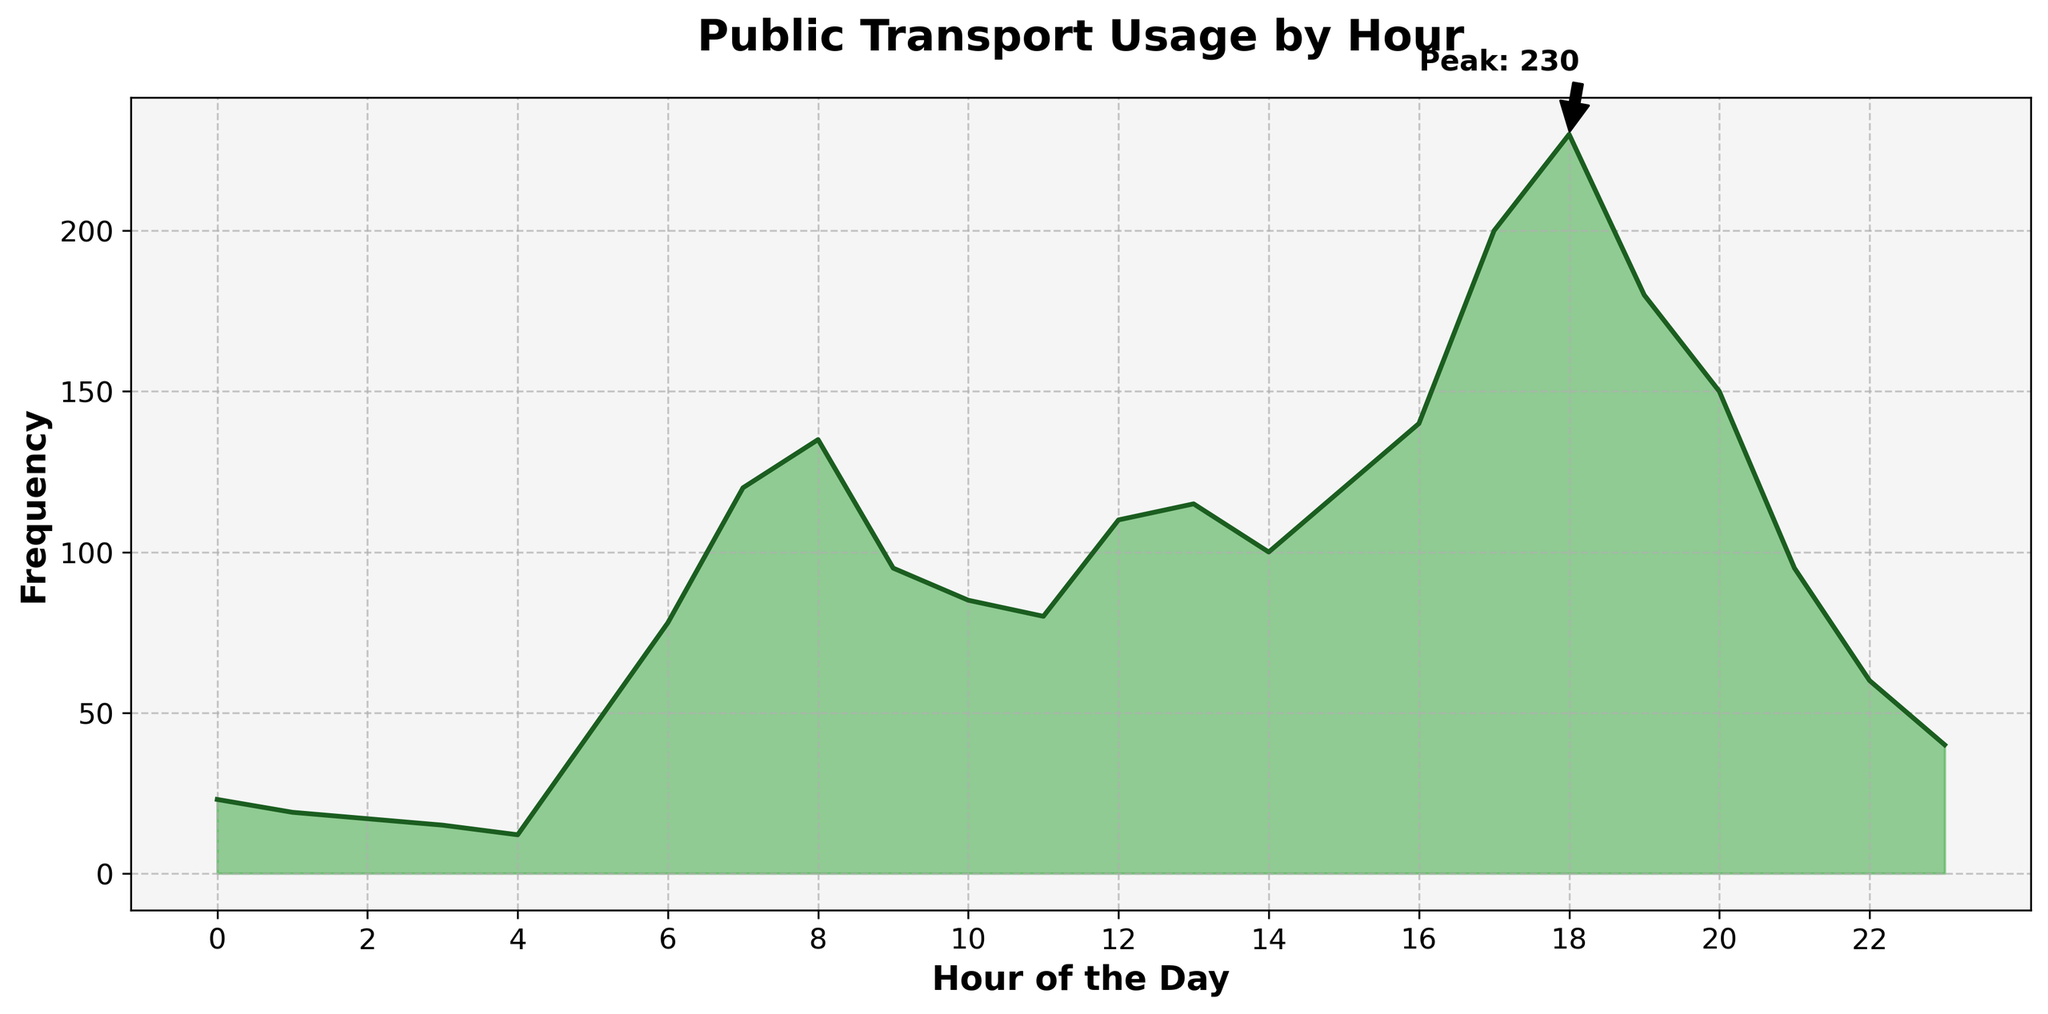What is the title of the figure? The title is usually located at the top of the figure and clearly states what the figure is about. In this case, it is "Public Transport Usage by Hour".
Answer: Public Transport Usage by Hour Which hour has the peak frequency of public transport usage? The peak hour can be seen where the frequency is annotated with "Peak: 230" on the figure.
Answer: 17 What color is used to fill the area under the density plot? The fill color under the density plot is a specific shade of green that can be visually identified.
Answer: Green How many major tick marks are on the x-axis? The x-axis corresponds to the hours of the day, and major tick marks are at 2-hour intervals. You can count these intervals starting from 0 to 22.
Answer: 12 What is the frequency at 8 AM? Locate 8 on the x-axis and trace vertically to where it intersects the plotted line, which shows the frequency value. This is given as 135 in the original data.
Answer: 135 What is the difference in frequency between 6 AM and 10 AM? Find the frequencies at 6 AM (78) and 10 AM (85) from the data. Then, compute the difference: 85 - 78.
Answer: 7 At what hour does the frequency first exceed 100? Trace the density plot and data points to find when the frequency first goes from below 100 to above 100. According to the data, it first reaches 100 at 7 AM with a frequency of 120.
Answer: 7 What is the average frequency of transport usage between 5 PM and 8 PM? Identify the frequencies at 5 PM (17: 200), 6 PM (18: 230), 7 PM (19: 180), and 8 PM (20: 150). Then compute the average: (200 + 230 + 180 + 150) / 4.
Answer: 190 What is the trend in public transport usage before 5 AM? Observe the frequency values from 0 AM to 4 AM and describe whether they increase or decrease. The values show a downward trend (23, 19, 17, 15, 12).
Answer: Decreasing What is the lowest frequency recorded, and at what hour does it occur? Scan through the frequency data to find the minimum value and the corresponding hour. The lowest frequency recorded is 12 at 4 AM.
Answer: 12 at 4 AM 